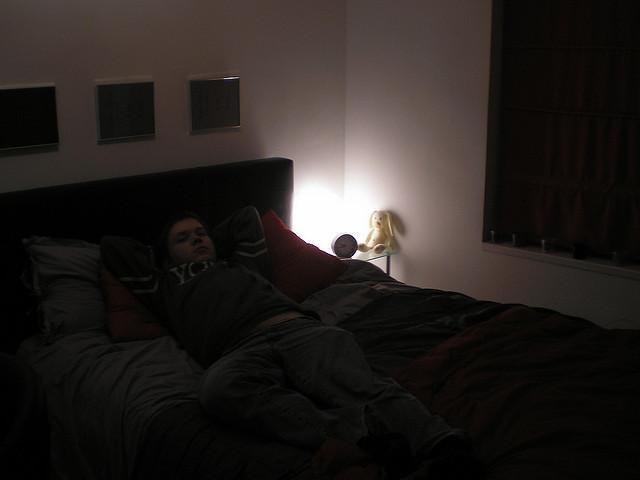How many pillows can be seen on the bed?
Give a very brief answer. 3. How many kids are laying on the bed?
Give a very brief answer. 1. How many people are sleeping on the bed?
Give a very brief answer. 1. How many framed pictures can be seen?
Give a very brief answer. 3. How many creatures are sleeping?
Give a very brief answer. 1. 